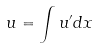Convert formula to latex. <formula><loc_0><loc_0><loc_500><loc_500>u = \int u ^ { \prime } d x</formula> 